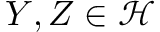<formula> <loc_0><loc_0><loc_500><loc_500>Y , Z \in { \mathcal { H } }</formula> 